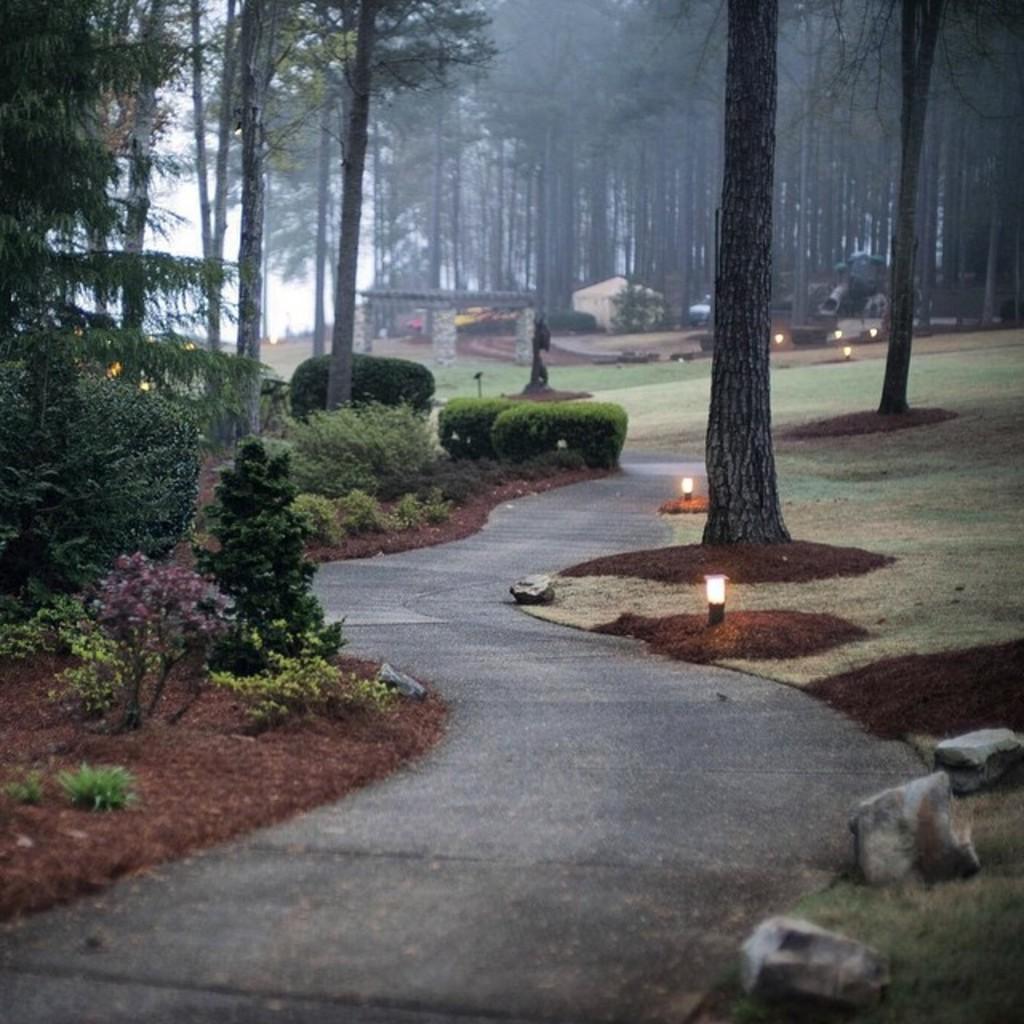Can you describe this image briefly? In the foreground of this image, there is a path on either side there are trees. On the left, there are few plants. On the right, there are few lights on the grassland. In the background, there are trees, shelter and the sky. 